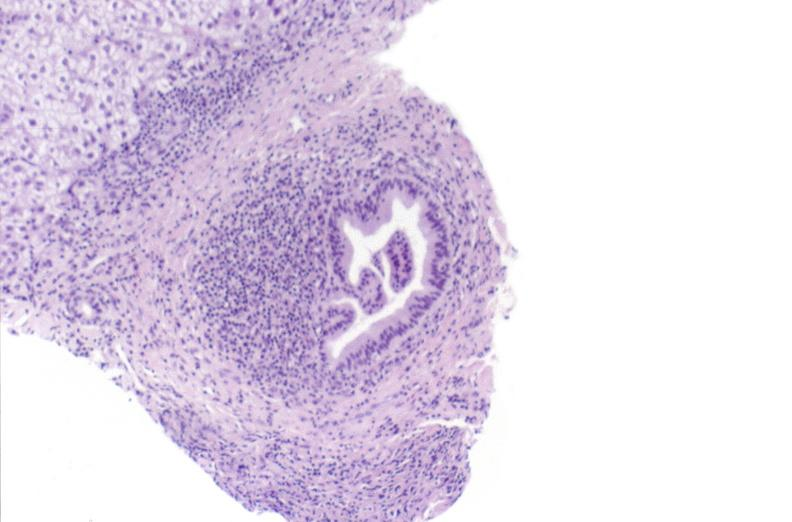does abruption show primary biliary cirrhosis?
Answer the question using a single word or phrase. No 